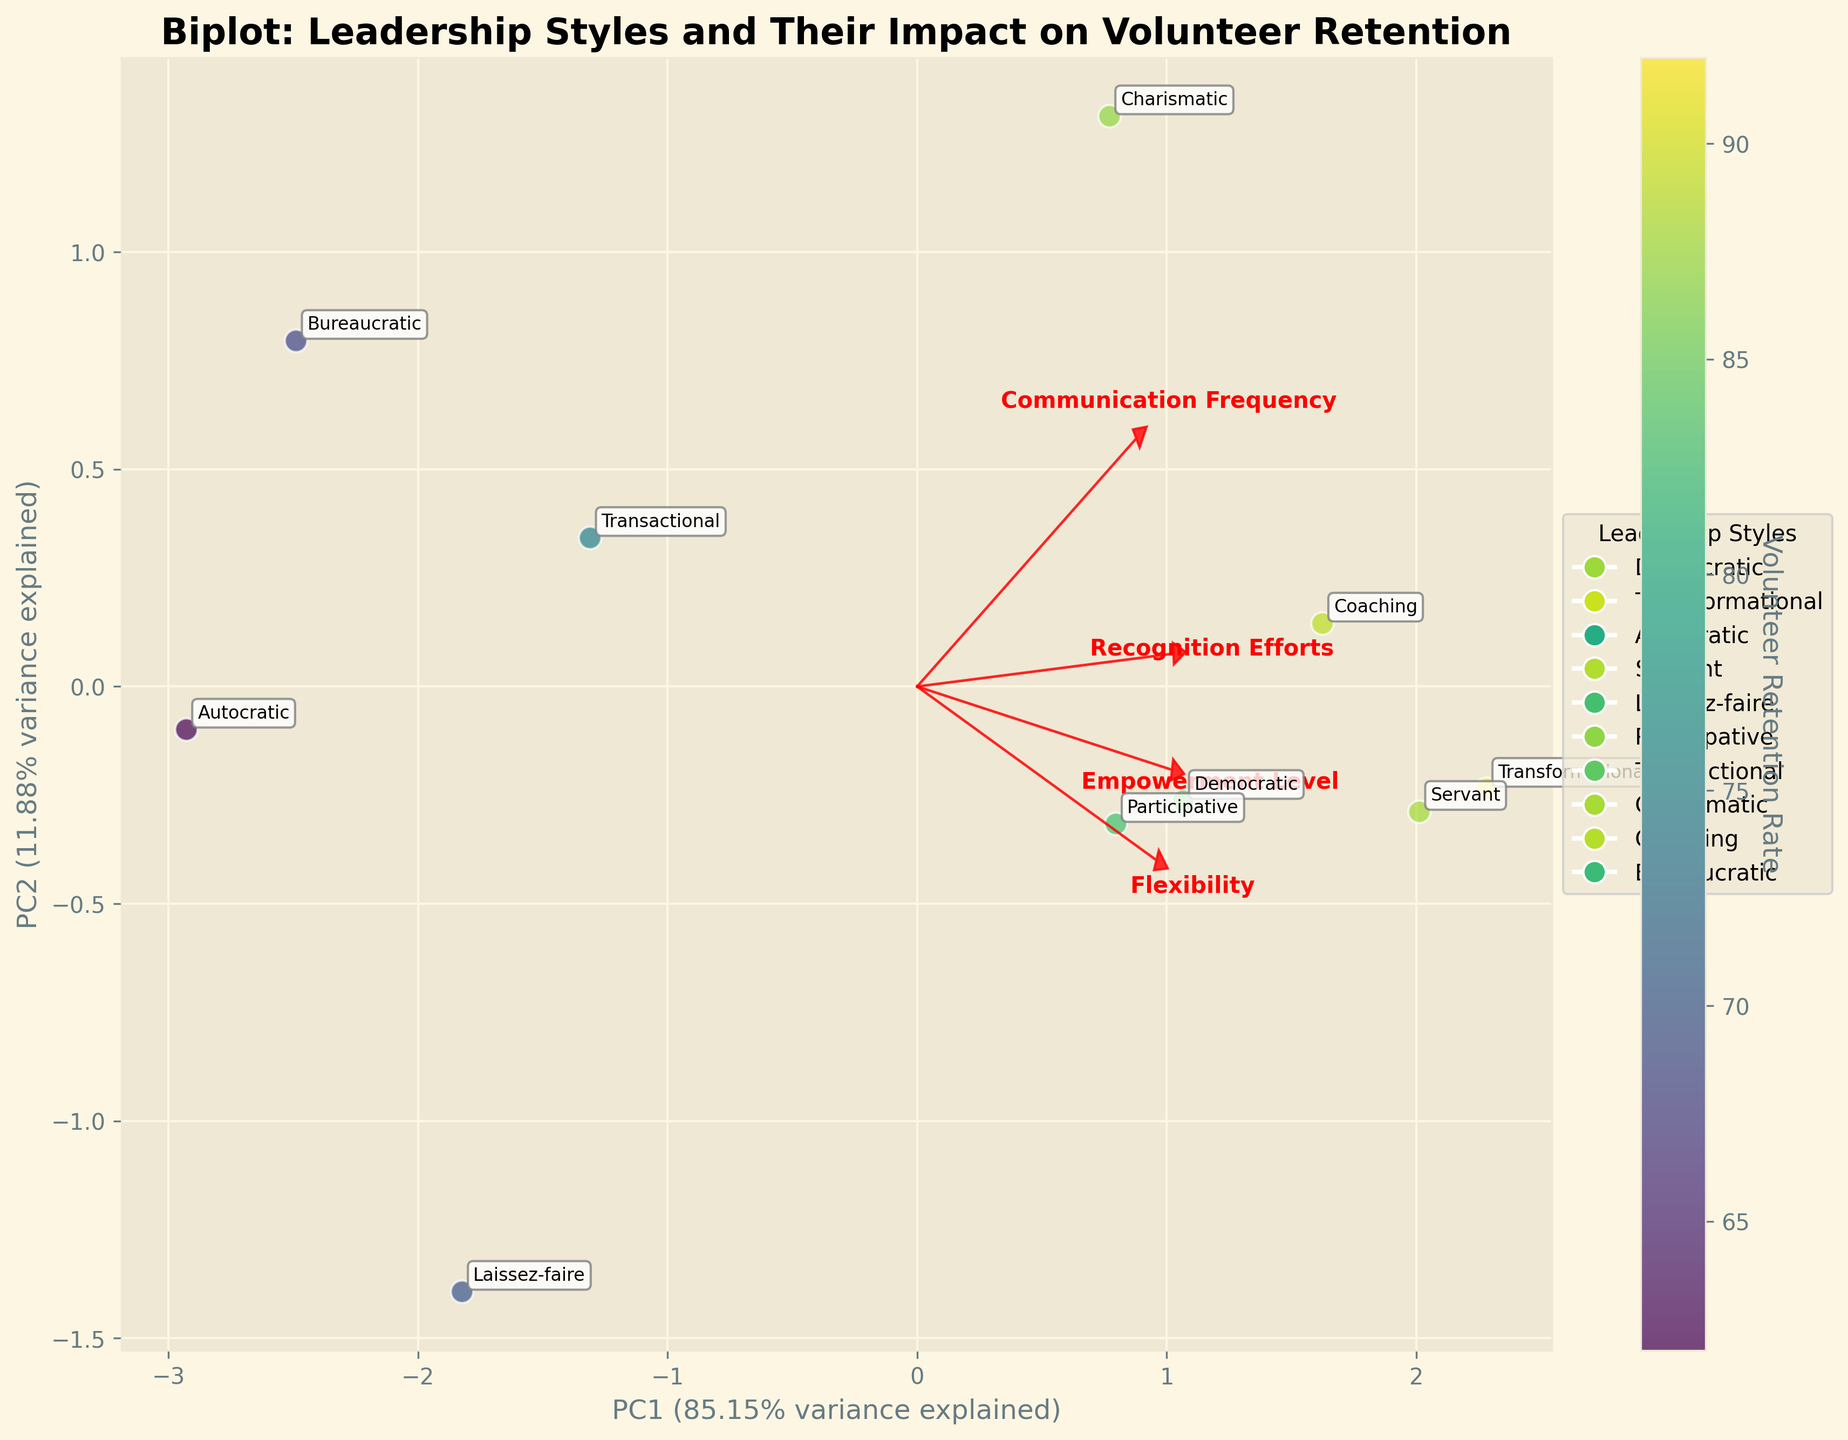What is the title of the biplot? The title is typically displayed at the top of the figure. Here, it is clearly written as "Biplot: Leadership Styles and Their Impact on Volunteer Retention".
Answer: Biplot: Leadership Styles and Their Impact on Volunteer Retention Which two axes are shown in the biplot and what do they represent? The axes in a biplot are usually labeled along the edge. In this case, the x-axis represents 'PC1' with its variance explained percentage, and the y-axis represents 'PC2' with its variance explained percentage.
Answer: PC1 and PC2 What feature is represented by the longest red arrow in the biplot? The biplot includes vectors (arrows) for each feature, with lengths indicating importance. The longest arrow signifies the 'Recognition Efforts' feature, evidenced by its length and label.
Answer: Recognition Efforts How many unique leadership styles are depicted in the biplot? The number of unique labels or points in the plot can be counted. Here, ten data points, each annotated with a different leadership style, show ten unique styles.
Answer: 10 Which leadership style has the highest Volunteer Retention Rate, according to the biplot’s color gradient? The color gradient indicates retention rates, with a deeper shade representing higher values. A close look shows 'Transformational' as the darkest point, denoting the highest rate.
Answer: Transformational Which leadership style has the lowest Empowerment Level according to the plot? Empowerment Level can be inferred from the PC1 and PC2 component scores and their vectors. 'Autocratic' has the lowest score along the vector representing Empowerment Level.
Answer: Autocratic What is the approximate range of the Volunteer Retention Rate represented in the biplot? The color bar on the right of the biplot indicates ranges. Observing it shows minimum rates around 62% for 'Autocratic' and maximums near 92% for 'Transformational'.
Answer: Approximately 62% to 92% Which two leadership styles are closest to each other on the biplot? Spatial positions of data points can be observed. 'Participative' and 'Democratic' are closest, indicating similar properties across the principal components analyzed.
Answer: Participative and Democratic Compare the flexibility scores of 'Laissez-faire' and 'Transactional' leadership styles. Which is higher? The vectors and the associated scores can be assessed. 'Laissez-faire' scores 7 for Flexibility, which is higher than 'Transactional's' score of 6.
Answer: Laissez-faire Based on the biplot, which feature appears to contribute most similarly to PC1 and PC2? The orientation and length of feature vectors reveal their contributions. 'Communication Frequency' appears nearly balanced in its contributions to both PC1 and PC2 due to its 45-degree angle placement.
Answer: Communication Frequency 